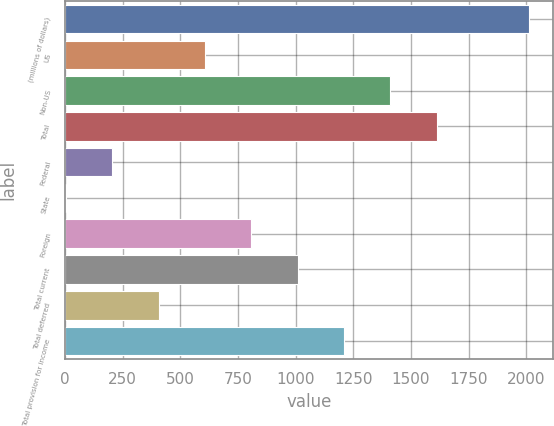<chart> <loc_0><loc_0><loc_500><loc_500><bar_chart><fcel>(millions of dollars)<fcel>US<fcel>Non-US<fcel>Total<fcel>Federal<fcel>State<fcel>Foreign<fcel>Total current<fcel>Total deferred<fcel>Total provision for income<nl><fcel>2014<fcel>606.93<fcel>1410.97<fcel>1611.98<fcel>204.91<fcel>3.9<fcel>807.94<fcel>1008.95<fcel>405.92<fcel>1209.96<nl></chart> 